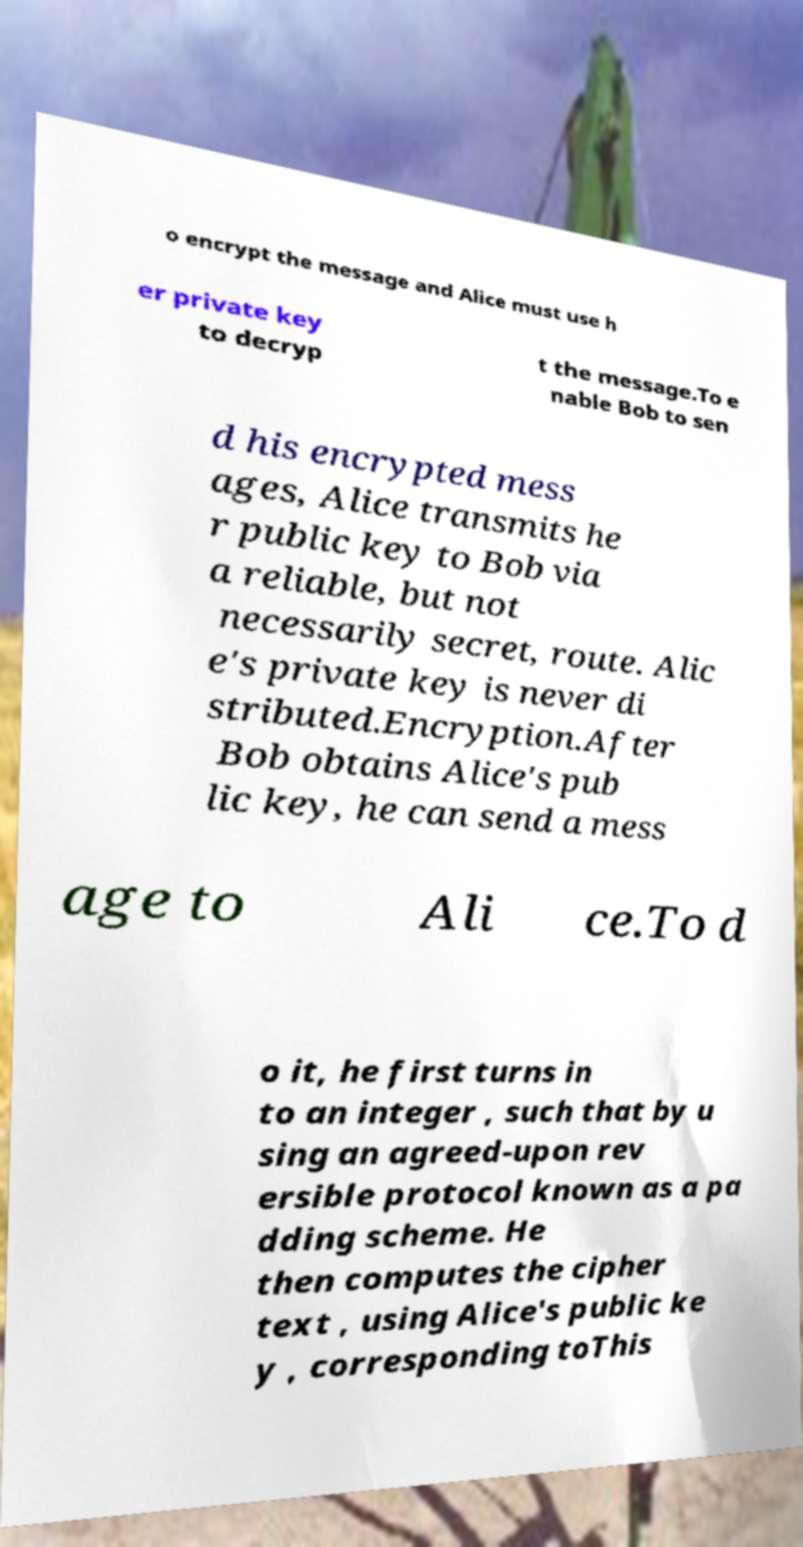Could you extract and type out the text from this image? o encrypt the message and Alice must use h er private key to decryp t the message.To e nable Bob to sen d his encrypted mess ages, Alice transmits he r public key to Bob via a reliable, but not necessarily secret, route. Alic e's private key is never di stributed.Encryption.After Bob obtains Alice's pub lic key, he can send a mess age to Ali ce.To d o it, he first turns in to an integer , such that by u sing an agreed-upon rev ersible protocol known as a pa dding scheme. He then computes the cipher text , using Alice's public ke y , corresponding toThis 